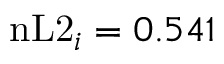<formula> <loc_0><loc_0><loc_500><loc_500>n L 2 _ { i } = 0 . 5 4 1</formula> 